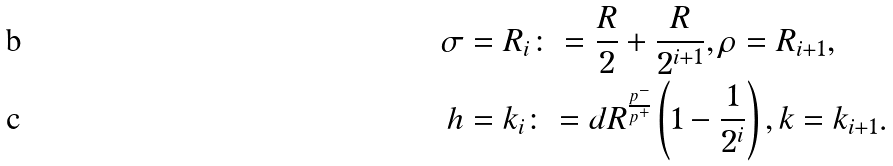Convert formula to latex. <formula><loc_0><loc_0><loc_500><loc_500>\sigma & = R _ { i } \colon = \frac { R } { 2 } + \frac { R } { 2 ^ { i + 1 } } , \rho = R _ { i + 1 } , \\ h & = k _ { i } \colon = d R ^ { \frac { p ^ { - } } { p ^ { + } } } \left ( 1 - \frac { 1 } { 2 ^ { i } } \right ) , k = k _ { i + 1 } .</formula> 